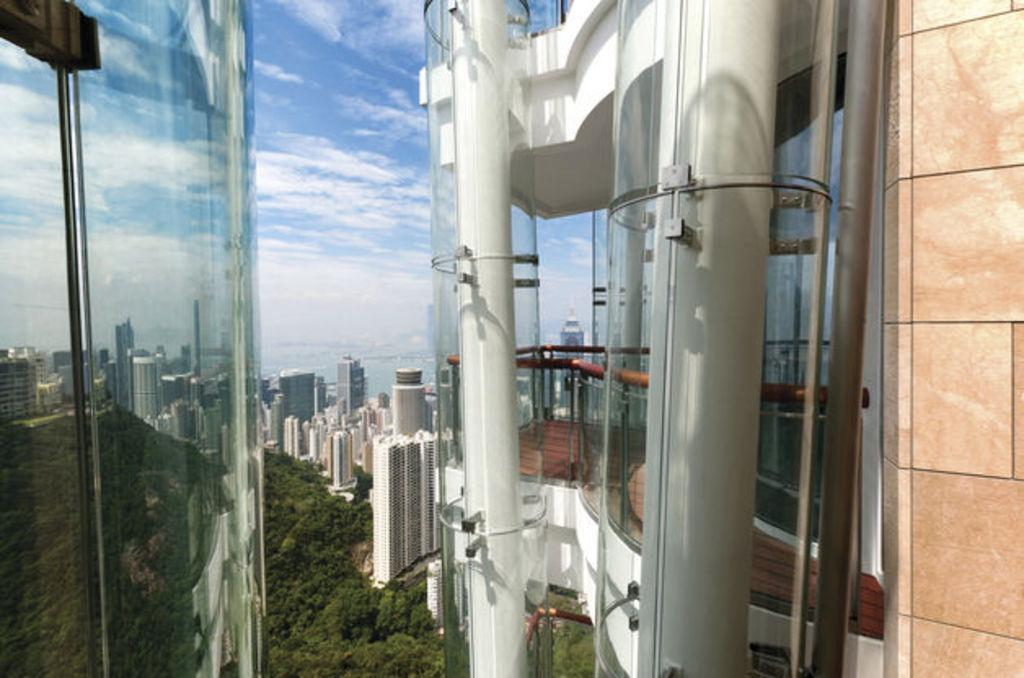What type of structures can be seen in the image? There are buildings in the image. What natural elements are present in the image? There are trees in the image. What part of the natural environment is visible in the image? The sky is visible in the image. What type of architectural feature can be seen in the image? There are framed glass walls in the image. Can you describe any other objects present in the image? There are other objects present in the image, but their specific details are not mentioned in the provided facts. What type of news can be seen on the card held by the fish in the image? There is no card or fish present in the image; it features buildings, trees, the sky, and framed glass walls. 